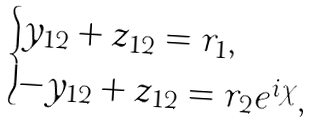<formula> <loc_0><loc_0><loc_500><loc_500>\begin{cases} y _ { 1 2 } + z _ { 1 2 } = r _ { 1 } , \\ - y _ { 1 2 } + z _ { 1 2 } = r _ { 2 } e ^ { i \chi } , \end{cases}</formula> 